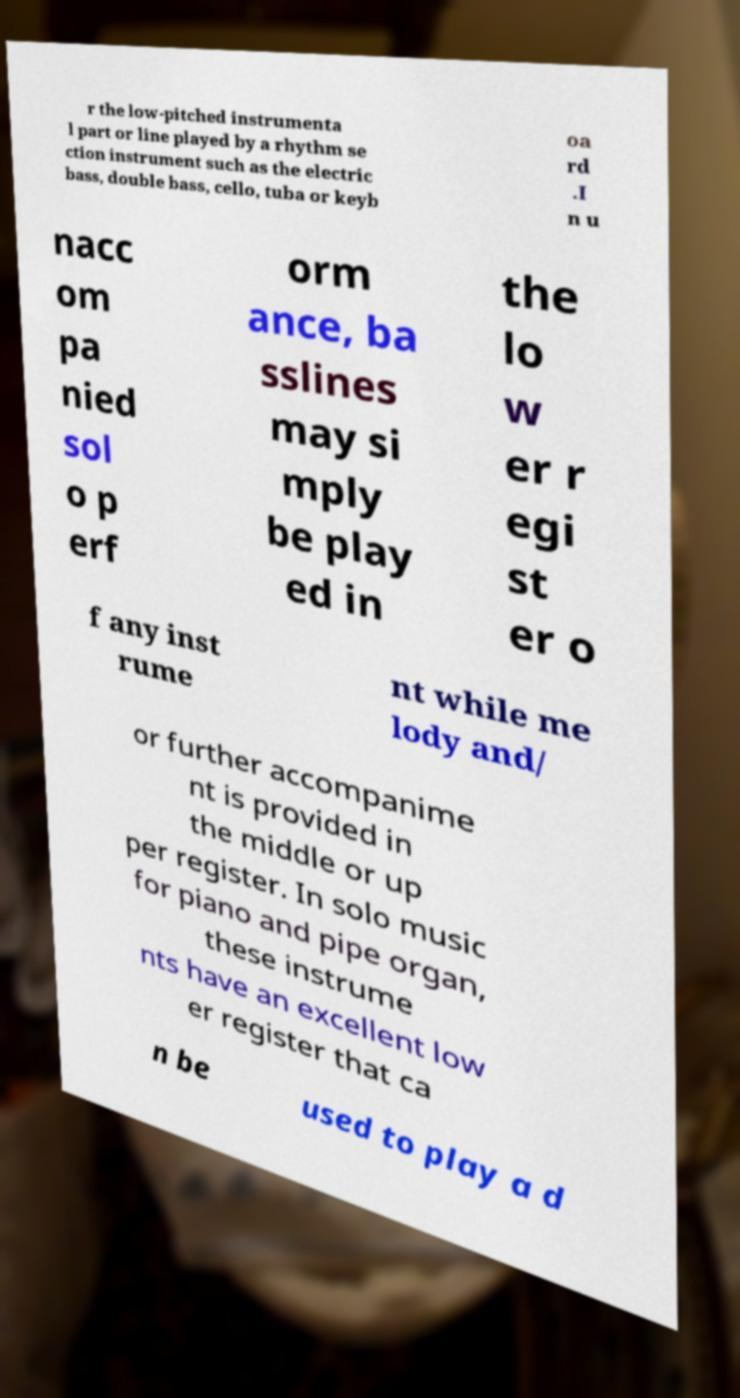For documentation purposes, I need the text within this image transcribed. Could you provide that? r the low-pitched instrumenta l part or line played by a rhythm se ction instrument such as the electric bass, double bass, cello, tuba or keyb oa rd .I n u nacc om pa nied sol o p erf orm ance, ba sslines may si mply be play ed in the lo w er r egi st er o f any inst rume nt while me lody and/ or further accompanime nt is provided in the middle or up per register. In solo music for piano and pipe organ, these instrume nts have an excellent low er register that ca n be used to play a d 